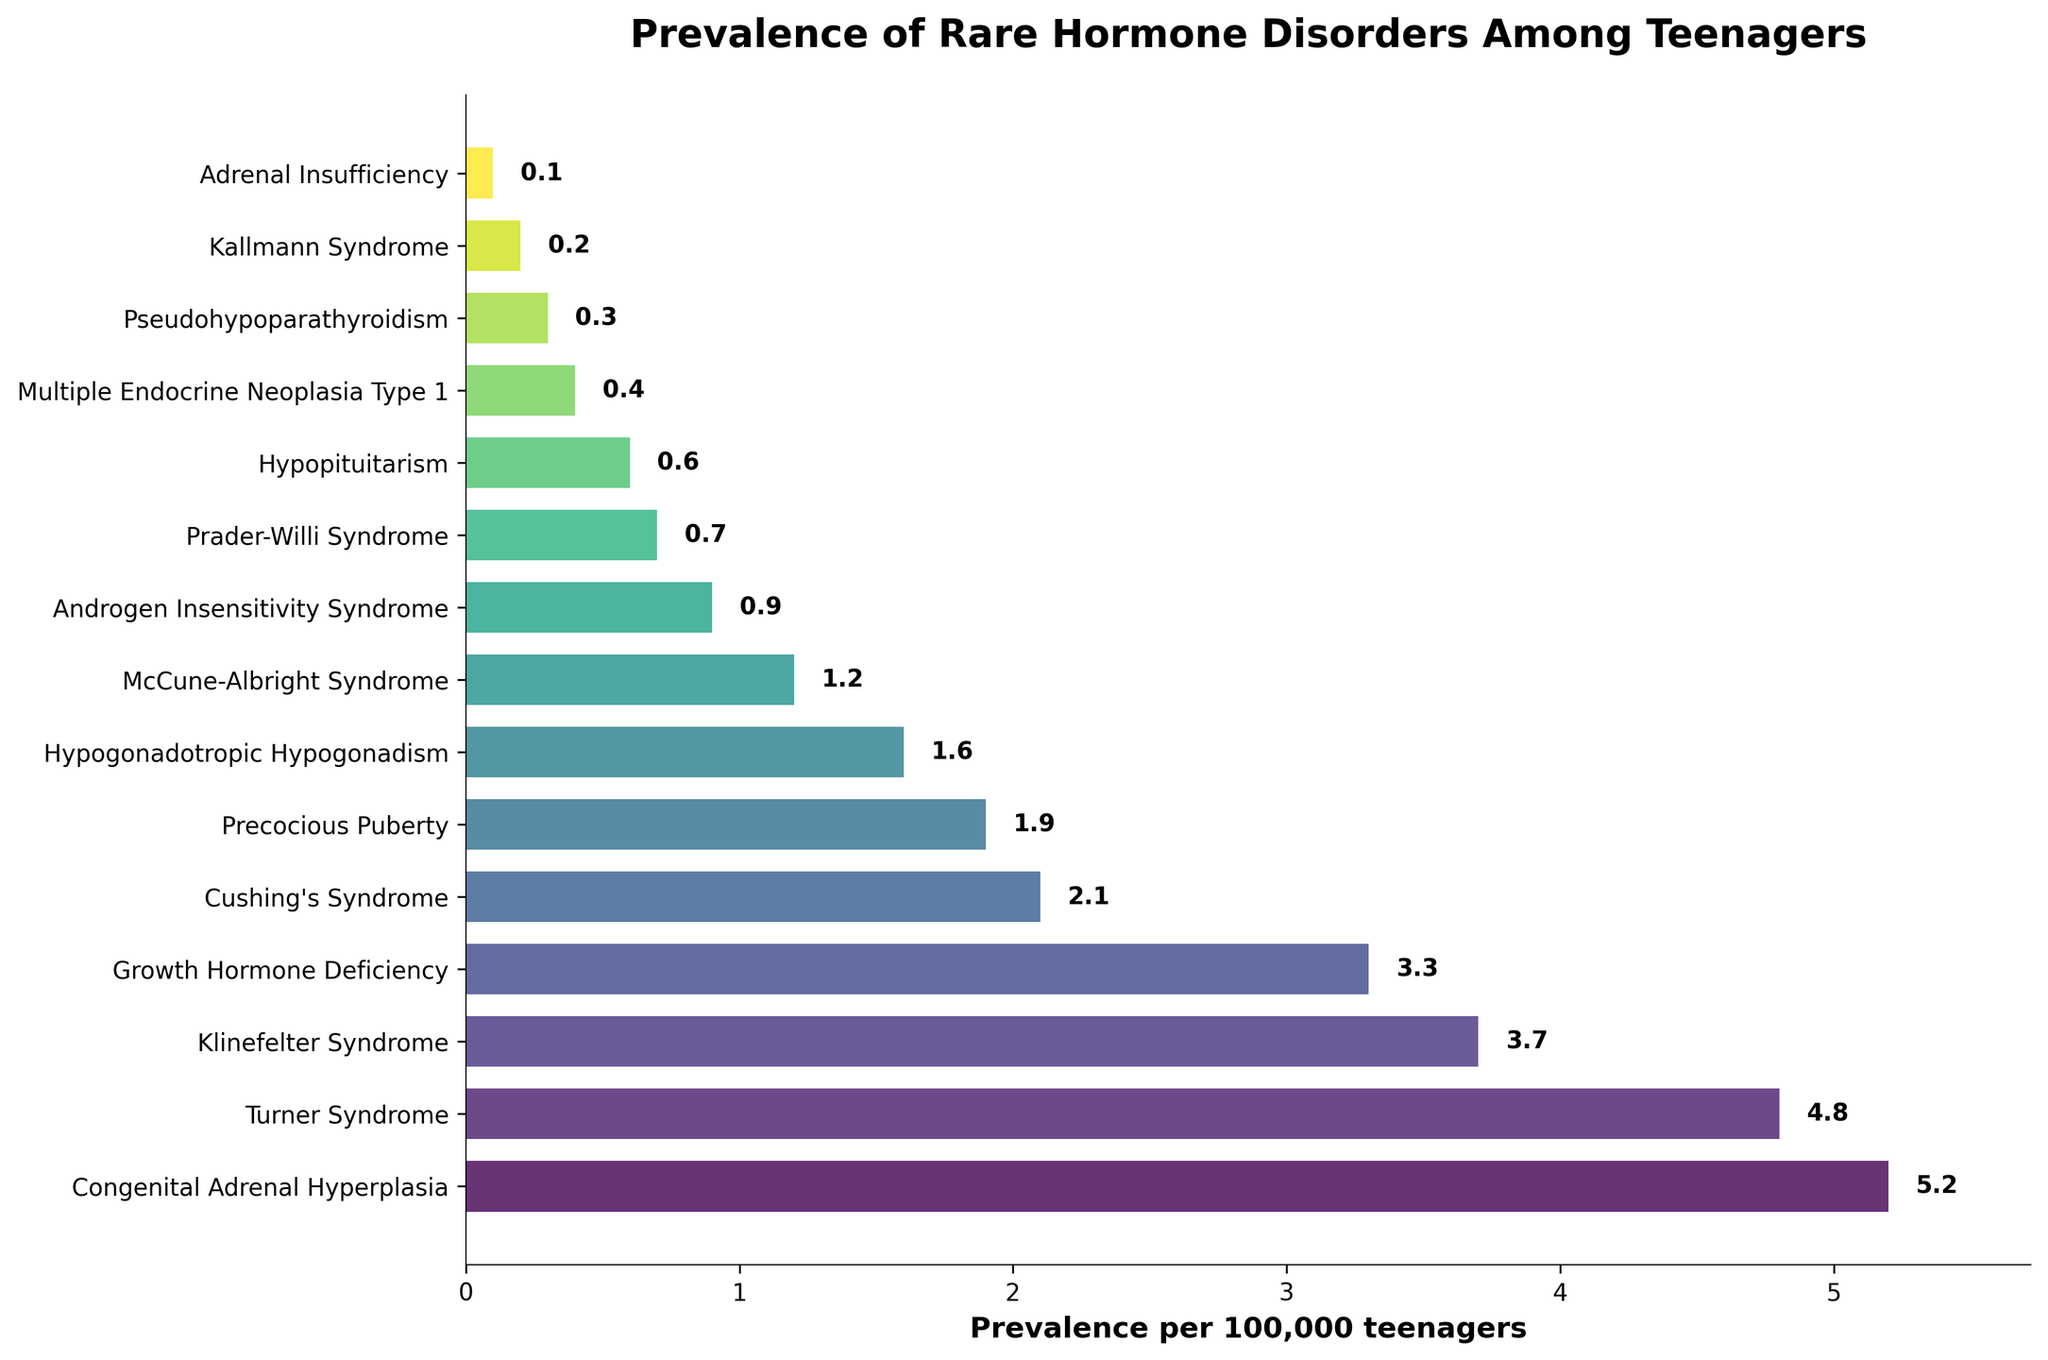Which condition has the highest prevalence? The bar for "Congenital Adrenal Hyperplasia" is the longest in the chart, reaching the highest value on the x-axis.
Answer: Congenital Adrenal Hyperplasia Which condition has the lowest prevalence? The bar for "Adrenal Insufficiency" is the shortest in the chart, reaching the lowest value on the x-axis.
Answer: Adrenal Insufficiency How much more prevalent is Congenital Adrenal Hyperplasia compared to Turner Syndrome? Congenital Adrenal Hyperplasia has a prevalence of 5.2, while Turner Syndrome has a prevalence of 4.8. Subtracting these values (5.2 - 4.8) gives the difference.
Answer: 0.4 What is the combined prevalence of Klinefelter Syndrome and Cushing's Syndrome? Klinefelter Syndrome has a prevalence of 3.7 and Cushing's Syndrome has a prevalence of 2.1. Adding these values (3.7 + 2.1) gives the combined prevalence.
Answer: 5.8 Which condition is more prevalent, Hypopituitarism or Prader-Willi Syndrome? The bar for Hypopituitarism reaches 0.6, while the bar for Prader-Willi Syndrome reaches 0.7. Therefore, Prader-Willi Syndrome is more prevalent.
Answer: Prader-Willi Syndrome What is the average prevalence of Precocious Puberty, Hypogonadotropic Hypogonadism, and McCune-Albright Syndrome? The prevalences are 1.9, 1.6, and 1.2, respectively. Summing these values (1.9 + 1.6 + 1.2) gives 4.7. Dividing by the number of conditions (4.7 / 3) gives the average.
Answer: 1.57 Is Growth Hormone Deficiency more prevalent than Turner Syndrome? The bar for Growth Hormone Deficiency reaches 3.3, while the bar for Turner Syndrome reaches 4.8. Thus, Growth Hormone Deficiency is less prevalent.
Answer: No What is the total prevalence for the three least common conditions? The prevalences for the least common conditions (Adrenal Insufficiency, Kallmann Syndrome, and Pseudohypoparathyroidism) are 0.1, 0.2, and 0.3, respectively. Summing these values (0.1 + 0.2 + 0.3) gives the total prevalence.
Answer: 0.6 Which condition has a prevalence closest to the median value of all conditions? The median value is the middle value in an ordered list of prevalences. Sorting the prevalences, the middle value is 1.6, which corresponds to Hypogonadotropic Hypogonadism.
Answer: Hypogonadotropic Hypogonadism 